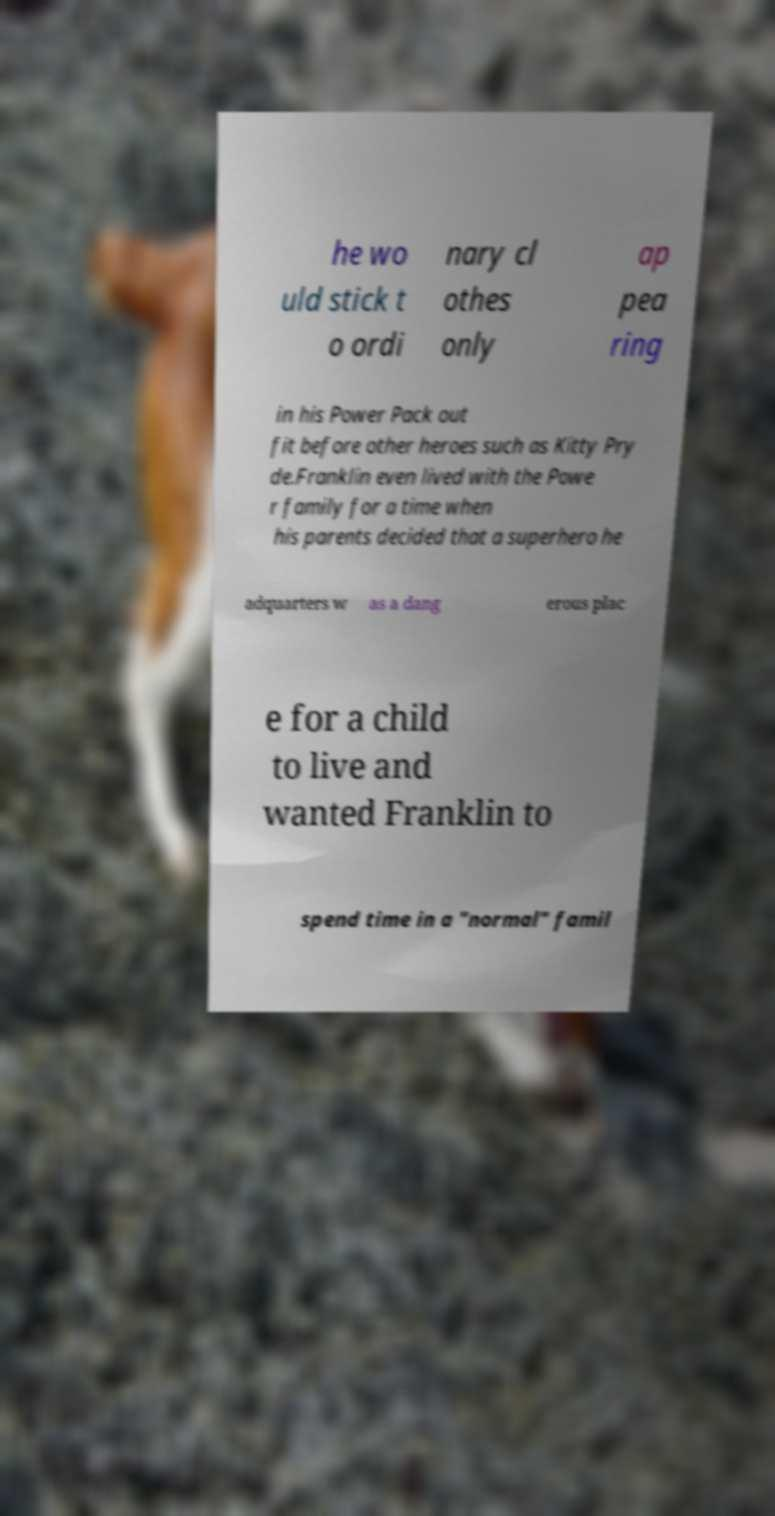Could you assist in decoding the text presented in this image and type it out clearly? he wo uld stick t o ordi nary cl othes only ap pea ring in his Power Pack out fit before other heroes such as Kitty Pry de.Franklin even lived with the Powe r family for a time when his parents decided that a superhero he adquarters w as a dang erous plac e for a child to live and wanted Franklin to spend time in a "normal" famil 